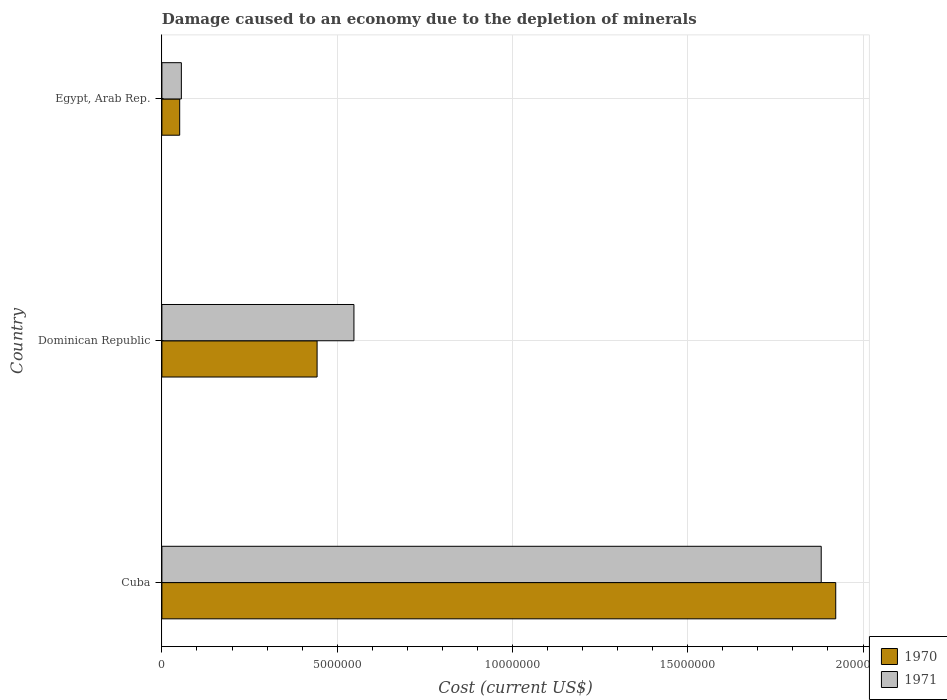How many groups of bars are there?
Give a very brief answer. 3. Are the number of bars per tick equal to the number of legend labels?
Offer a terse response. Yes. Are the number of bars on each tick of the Y-axis equal?
Offer a terse response. Yes. How many bars are there on the 3rd tick from the top?
Your response must be concise. 2. How many bars are there on the 1st tick from the bottom?
Offer a terse response. 2. What is the label of the 1st group of bars from the top?
Offer a very short reply. Egypt, Arab Rep. What is the cost of damage caused due to the depletion of minerals in 1970 in Dominican Republic?
Make the answer very short. 4.43e+06. Across all countries, what is the maximum cost of damage caused due to the depletion of minerals in 1971?
Offer a terse response. 1.88e+07. Across all countries, what is the minimum cost of damage caused due to the depletion of minerals in 1970?
Offer a very short reply. 5.07e+05. In which country was the cost of damage caused due to the depletion of minerals in 1970 maximum?
Offer a very short reply. Cuba. In which country was the cost of damage caused due to the depletion of minerals in 1971 minimum?
Your answer should be compact. Egypt, Arab Rep. What is the total cost of damage caused due to the depletion of minerals in 1970 in the graph?
Make the answer very short. 2.42e+07. What is the difference between the cost of damage caused due to the depletion of minerals in 1970 in Cuba and that in Egypt, Arab Rep.?
Offer a terse response. 1.87e+07. What is the difference between the cost of damage caused due to the depletion of minerals in 1970 in Egypt, Arab Rep. and the cost of damage caused due to the depletion of minerals in 1971 in Cuba?
Offer a very short reply. -1.83e+07. What is the average cost of damage caused due to the depletion of minerals in 1971 per country?
Offer a very short reply. 8.28e+06. What is the difference between the cost of damage caused due to the depletion of minerals in 1971 and cost of damage caused due to the depletion of minerals in 1970 in Dominican Republic?
Make the answer very short. 1.05e+06. What is the ratio of the cost of damage caused due to the depletion of minerals in 1970 in Cuba to that in Egypt, Arab Rep.?
Offer a very short reply. 37.89. Is the difference between the cost of damage caused due to the depletion of minerals in 1971 in Dominican Republic and Egypt, Arab Rep. greater than the difference between the cost of damage caused due to the depletion of minerals in 1970 in Dominican Republic and Egypt, Arab Rep.?
Ensure brevity in your answer.  Yes. What is the difference between the highest and the second highest cost of damage caused due to the depletion of minerals in 1971?
Your answer should be compact. 1.33e+07. What is the difference between the highest and the lowest cost of damage caused due to the depletion of minerals in 1970?
Give a very brief answer. 1.87e+07. In how many countries, is the cost of damage caused due to the depletion of minerals in 1970 greater than the average cost of damage caused due to the depletion of minerals in 1970 taken over all countries?
Your answer should be compact. 1. Are all the bars in the graph horizontal?
Your answer should be compact. Yes. Does the graph contain any zero values?
Keep it short and to the point. No. How many legend labels are there?
Provide a succinct answer. 2. What is the title of the graph?
Provide a succinct answer. Damage caused to an economy due to the depletion of minerals. Does "2003" appear as one of the legend labels in the graph?
Offer a terse response. No. What is the label or title of the X-axis?
Give a very brief answer. Cost (current US$). What is the Cost (current US$) in 1970 in Cuba?
Ensure brevity in your answer.  1.92e+07. What is the Cost (current US$) of 1971 in Cuba?
Ensure brevity in your answer.  1.88e+07. What is the Cost (current US$) of 1970 in Dominican Republic?
Offer a very short reply. 4.43e+06. What is the Cost (current US$) of 1971 in Dominican Republic?
Provide a succinct answer. 5.48e+06. What is the Cost (current US$) in 1970 in Egypt, Arab Rep.?
Offer a terse response. 5.07e+05. What is the Cost (current US$) of 1971 in Egypt, Arab Rep.?
Your response must be concise. 5.55e+05. Across all countries, what is the maximum Cost (current US$) of 1970?
Provide a succinct answer. 1.92e+07. Across all countries, what is the maximum Cost (current US$) of 1971?
Your answer should be very brief. 1.88e+07. Across all countries, what is the minimum Cost (current US$) of 1970?
Your answer should be very brief. 5.07e+05. Across all countries, what is the minimum Cost (current US$) in 1971?
Make the answer very short. 5.55e+05. What is the total Cost (current US$) in 1970 in the graph?
Provide a succinct answer. 2.42e+07. What is the total Cost (current US$) of 1971 in the graph?
Offer a terse response. 2.48e+07. What is the difference between the Cost (current US$) of 1970 in Cuba and that in Dominican Republic?
Offer a terse response. 1.48e+07. What is the difference between the Cost (current US$) of 1971 in Cuba and that in Dominican Republic?
Keep it short and to the point. 1.33e+07. What is the difference between the Cost (current US$) of 1970 in Cuba and that in Egypt, Arab Rep.?
Your response must be concise. 1.87e+07. What is the difference between the Cost (current US$) of 1971 in Cuba and that in Egypt, Arab Rep.?
Offer a very short reply. 1.83e+07. What is the difference between the Cost (current US$) in 1970 in Dominican Republic and that in Egypt, Arab Rep.?
Your answer should be compact. 3.92e+06. What is the difference between the Cost (current US$) in 1971 in Dominican Republic and that in Egypt, Arab Rep.?
Ensure brevity in your answer.  4.92e+06. What is the difference between the Cost (current US$) of 1970 in Cuba and the Cost (current US$) of 1971 in Dominican Republic?
Offer a terse response. 1.37e+07. What is the difference between the Cost (current US$) of 1970 in Cuba and the Cost (current US$) of 1971 in Egypt, Arab Rep.?
Provide a short and direct response. 1.87e+07. What is the difference between the Cost (current US$) of 1970 in Dominican Republic and the Cost (current US$) of 1971 in Egypt, Arab Rep.?
Ensure brevity in your answer.  3.87e+06. What is the average Cost (current US$) in 1970 per country?
Ensure brevity in your answer.  8.05e+06. What is the average Cost (current US$) in 1971 per country?
Your answer should be very brief. 8.28e+06. What is the difference between the Cost (current US$) in 1970 and Cost (current US$) in 1971 in Cuba?
Ensure brevity in your answer.  4.14e+05. What is the difference between the Cost (current US$) in 1970 and Cost (current US$) in 1971 in Dominican Republic?
Offer a very short reply. -1.05e+06. What is the difference between the Cost (current US$) in 1970 and Cost (current US$) in 1971 in Egypt, Arab Rep.?
Your answer should be very brief. -4.79e+04. What is the ratio of the Cost (current US$) of 1970 in Cuba to that in Dominican Republic?
Offer a terse response. 4.34. What is the ratio of the Cost (current US$) of 1971 in Cuba to that in Dominican Republic?
Offer a very short reply. 3.43. What is the ratio of the Cost (current US$) in 1970 in Cuba to that in Egypt, Arab Rep.?
Your answer should be very brief. 37.89. What is the ratio of the Cost (current US$) of 1971 in Cuba to that in Egypt, Arab Rep.?
Offer a terse response. 33.88. What is the ratio of the Cost (current US$) in 1970 in Dominican Republic to that in Egypt, Arab Rep.?
Your answer should be very brief. 8.73. What is the ratio of the Cost (current US$) of 1971 in Dominican Republic to that in Egypt, Arab Rep.?
Provide a succinct answer. 9.87. What is the difference between the highest and the second highest Cost (current US$) of 1970?
Your answer should be compact. 1.48e+07. What is the difference between the highest and the second highest Cost (current US$) of 1971?
Provide a succinct answer. 1.33e+07. What is the difference between the highest and the lowest Cost (current US$) in 1970?
Your answer should be compact. 1.87e+07. What is the difference between the highest and the lowest Cost (current US$) of 1971?
Give a very brief answer. 1.83e+07. 